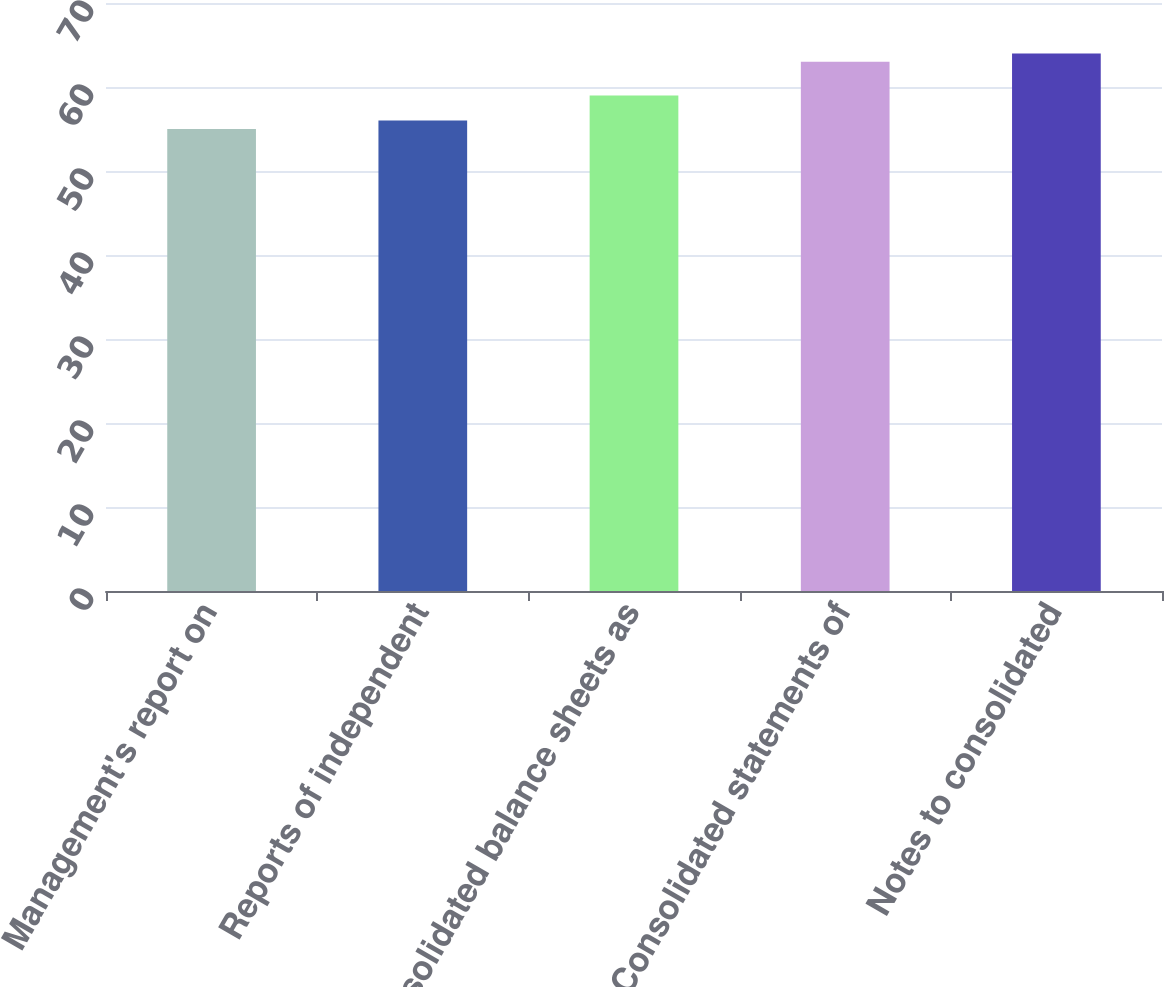Convert chart to OTSL. <chart><loc_0><loc_0><loc_500><loc_500><bar_chart><fcel>Management's report on<fcel>Reports of independent<fcel>Consolidated balance sheets as<fcel>Consolidated statements of<fcel>Notes to consolidated<nl><fcel>55<fcel>56<fcel>59<fcel>63<fcel>64<nl></chart> 